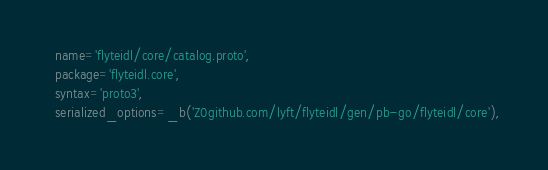Convert code to text. <code><loc_0><loc_0><loc_500><loc_500><_Python_>  name='flyteidl/core/catalog.proto',
  package='flyteidl.core',
  syntax='proto3',
  serialized_options=_b('Z0github.com/lyft/flyteidl/gen/pb-go/flyteidl/core'),</code> 